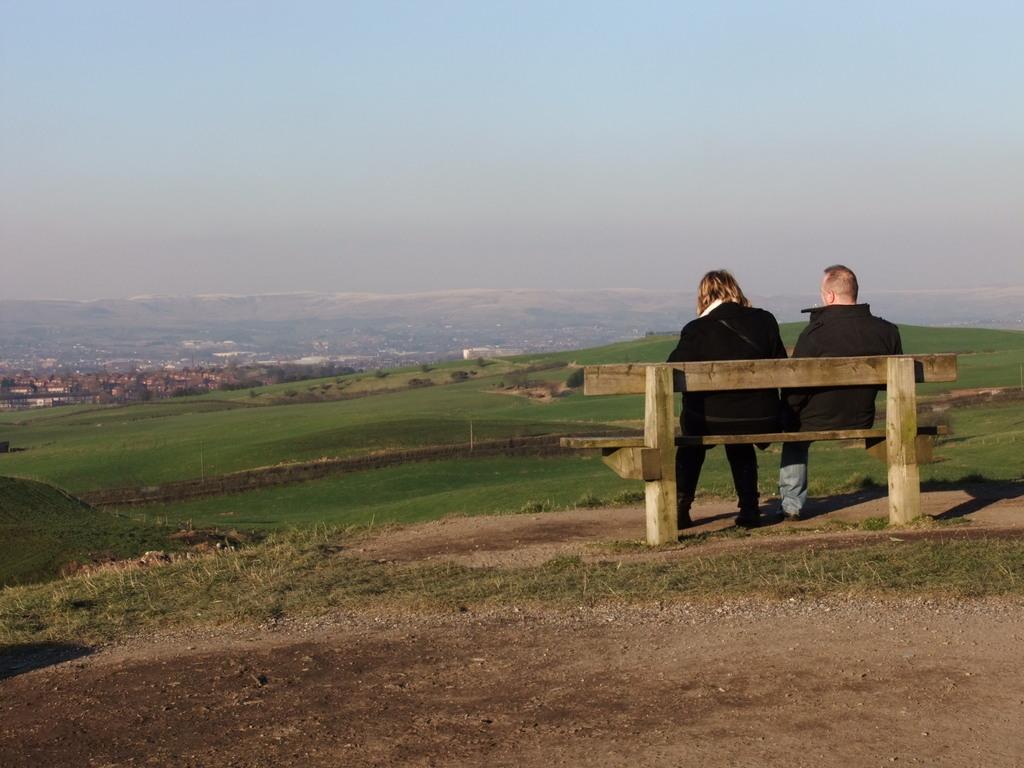How would you summarize this image in a sentence or two? In this image i can see two persons sitting on the bench,at the back ground i can see few buildings and a sky. 